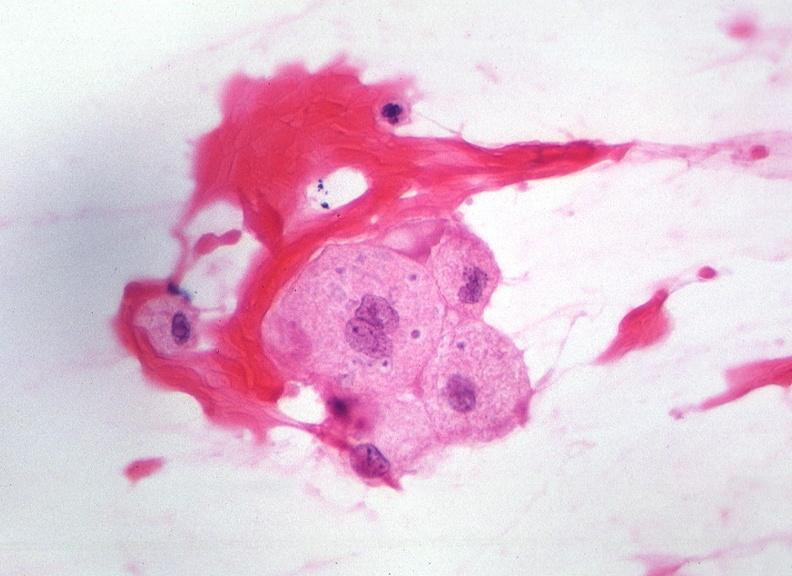what does this image show?
Answer the question using a single word or phrase. Touch impression from cerebrospinal fluid - toxoplasma 